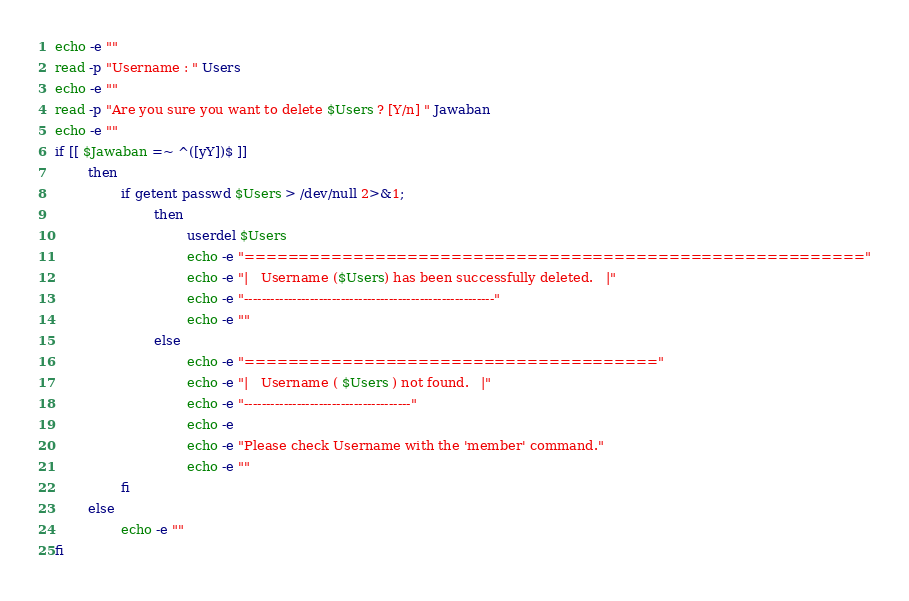Convert code to text. <code><loc_0><loc_0><loc_500><loc_500><_Bash_>echo -e ""
read -p "Username : " Users
echo -e ""
read -p "Are you sure you want to delete $Users ? [Y/n] " Jawaban
echo -e ""
if [[ $Jawaban =~ ^([yY])$ ]]
        then
                if getent passwd $Users > /dev/null 2>&1;
                        then
                                userdel $Users
                                echo -e "========================================================="
                                echo -e "|   Username ($Users) has been successfully deleted.   |"
                                echo -e "---------------------------------------------------------"
                                echo -e ""
                        else
                                echo -e "======================================"
                                echo -e "|   Username ( $Users ) not found.   |"
                                echo -e "--------------------------------------"
                                echo -e
                                echo -e "Please check Username with the 'member' command."
                                echo -e ""
                fi
        else
                echo -e ""
fi
</code> 